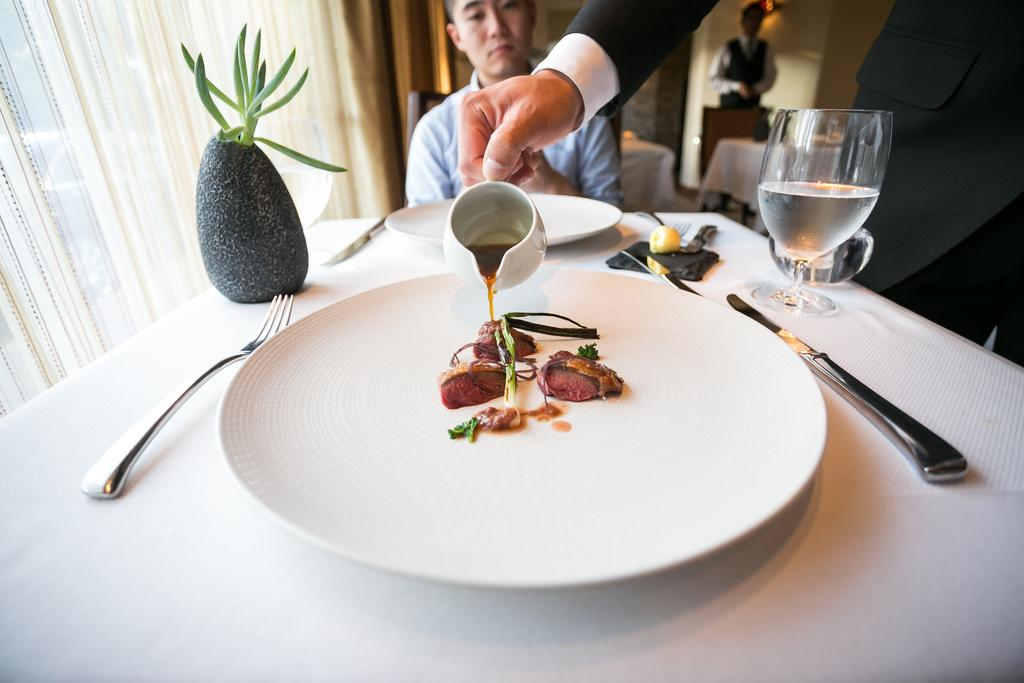What piece of furniture is present in the image? There is a table in the image. What is placed on the table? There is a plate, a fork, a glass, and a food item on the table. What utensil is visible on the table? There is a fork on the table. What type of dishware is present on the table? There is a glass on the table. What is the person in the image doing? There is a person sitting in a chair in the image. What can be seen in the background of the image? There is a wall visible in the background of the image. What type of railway can be seen in the image? There is no railway present in the image. Is there a pig visible in the image? No, there is no pig present in the image. 